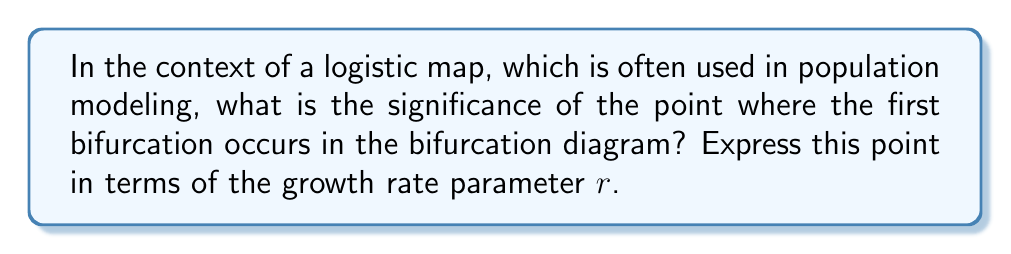Teach me how to tackle this problem. To understand this, let's break it down step-by-step:

1. The logistic map is defined by the equation:
   $$x_{n+1} = rx_n(1-x_n)$$
   where $r$ is the growth rate parameter.

2. The bifurcation diagram shows the long-term behavior of the system as $r$ changes.

3. For small values of $r$, the system converges to a single fixed point.

4. As $r$ increases, the system undergoes a series of bifurcations, where the number of periodic points doubles.

5. The first bifurcation occurs when the single fixed point splits into two periodic points.

6. This first bifurcation happens at a critical value of $r$, which we can calculate:

   a) The fixed point of the system is given by:
      $$x^* = rx^*(1-x^*)$$

   b) Solving this, we get:
      $$x^* = 0$$ or $$x^* = 1 - \frac{1}{r}$$

   c) The stability of this fixed point changes when:
      $$\left|\frac{d}{dx}(rx(1-x))\right|_{x=x^*} = 1$$

   d) Calculating this derivative and substituting $x^*$:
      $$|2-r| = 1$$

   e) Solving this equation:
      $$r = 3$$

7. Therefore, the first bifurcation occurs at $r = 3$.

8. This point is significant because it marks the transition from simple, predictable behavior to more complex, potentially chaotic behavior.

For a junior web developer learning about search methodologies and Firebase, this concept could be analogous to how small changes in search parameters or database rules can lead to significantly different results or system behaviors.
Answer: $r = 3$ 